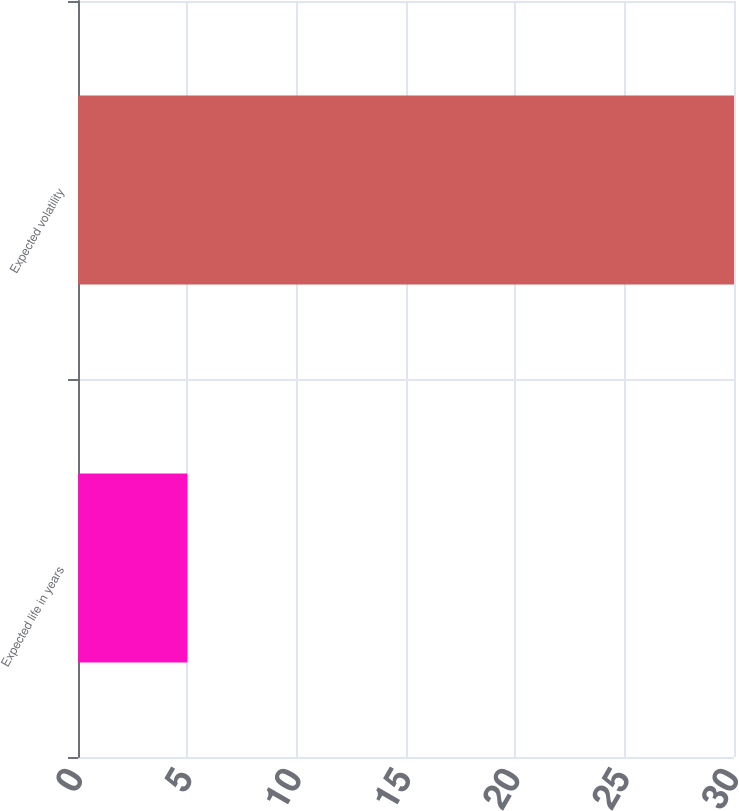Convert chart. <chart><loc_0><loc_0><loc_500><loc_500><bar_chart><fcel>Expected life in years<fcel>Expected volatility<nl><fcel>5<fcel>30<nl></chart> 